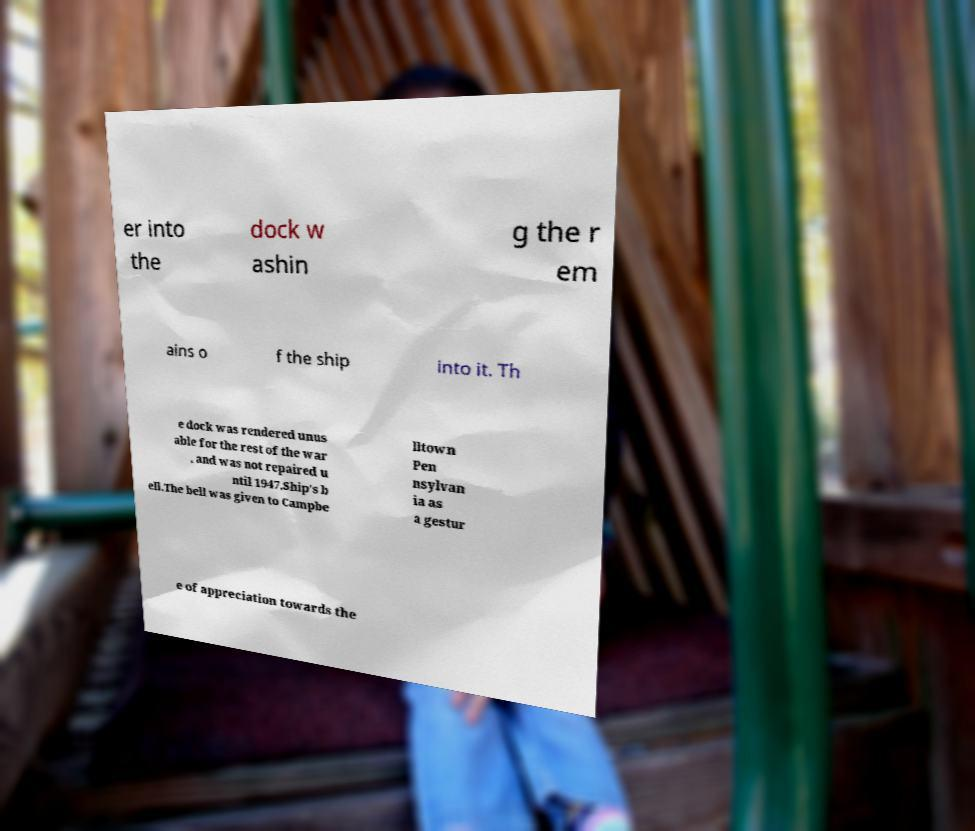Please identify and transcribe the text found in this image. er into the dock w ashin g the r em ains o f the ship into it. Th e dock was rendered unus able for the rest of the war , and was not repaired u ntil 1947.Ship's b ell.The bell was given to Campbe lltown Pen nsylvan ia as a gestur e of appreciation towards the 